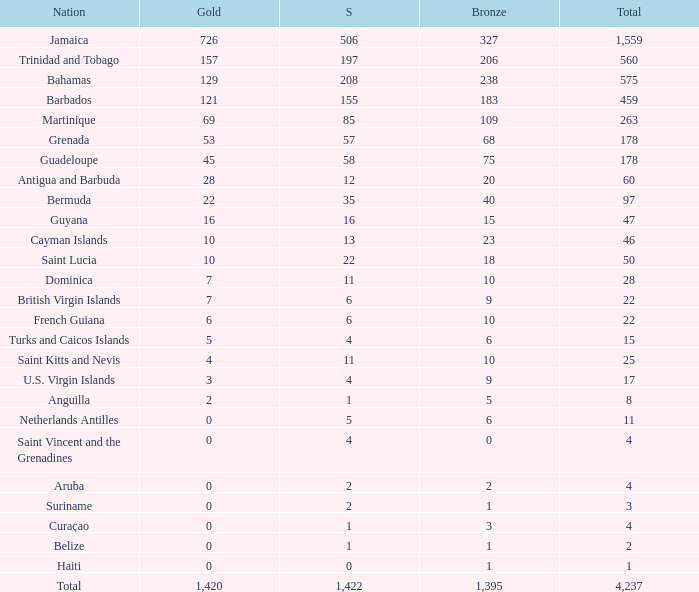What's the total number of Silver that has Gold that's larger than 0, Bronze that's smaller than 23, a Total that's larger than 22, and has the Nation of Saint Kitts and Nevis? 1.0. 